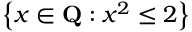<formula> <loc_0><loc_0><loc_500><loc_500>\left \{ x \in Q \colon x ^ { 2 } \leq 2 \right \}</formula> 